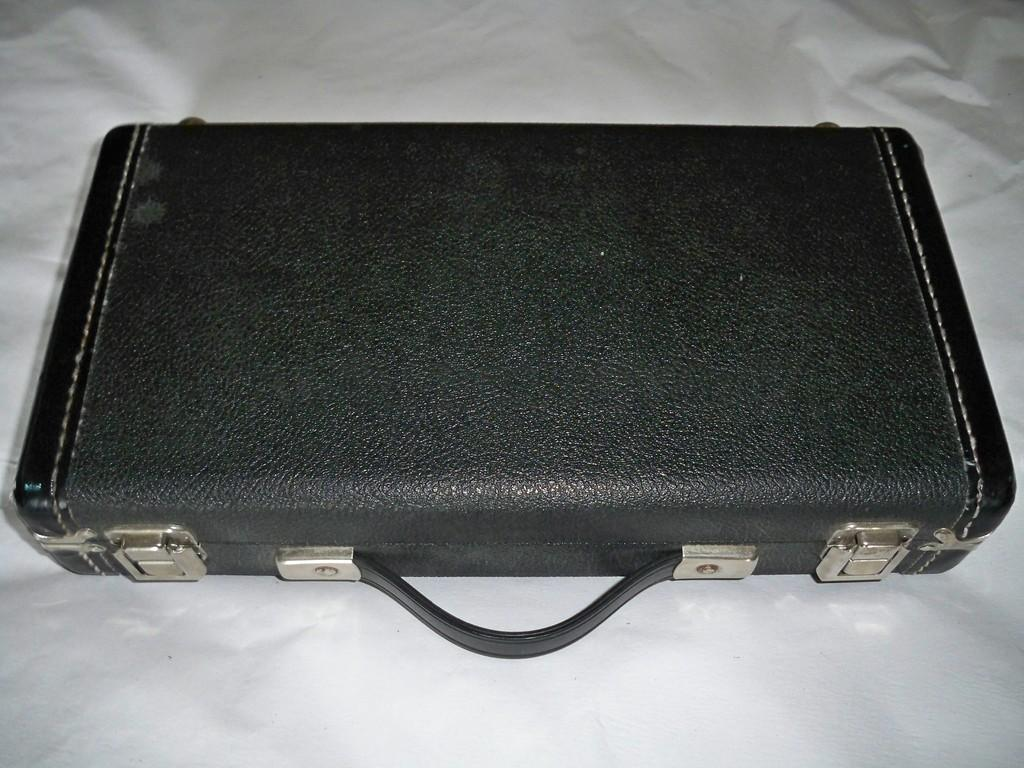What color is the suitcase in the image? The suitcase is black in color. Who is handling the suitcase in the image? The suitcase has a handler. What color are the straps on the suitcase? The suitcase has white straps. How does the suitcase show respect to the handler in the image? The suitcase does not show respect to the handler in the image, as it is an inanimate object and cannot display emotions or actions. 